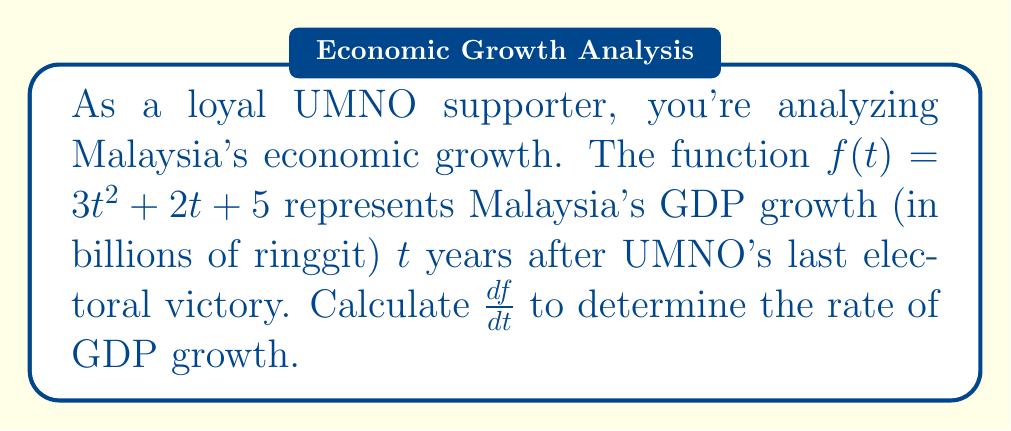Can you answer this question? To find the derivative of $f(t) = 3t^2 + 2t + 5$, we'll use the power rule and the constant rule:

1) For the term $3t^2$:
   $\frac{d}{dt}(3t^2) = 3 \cdot 2t = 6t$

2) For the term $2t$:
   $\frac{d}{dt}(2t) = 2$

3) For the constant term 5:
   $\frac{d}{dt}(5) = 0$

Now, we sum these results:

$\frac{df}{dt} = 6t + 2 + 0 = 6t + 2$

This derivative represents the rate of change of Malaysia's GDP growth under UMNO leadership, measured in billions of ringgit per year.
Answer: $\frac{df}{dt} = 6t + 2$ 